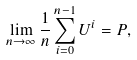Convert formula to latex. <formula><loc_0><loc_0><loc_500><loc_500>\lim _ { n \to \infty } \frac { 1 } { n } \sum _ { i = 0 } ^ { n - 1 } U ^ { i } = P ,</formula> 